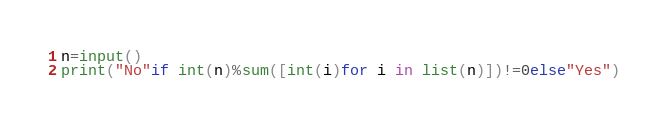<code> <loc_0><loc_0><loc_500><loc_500><_Python_>n=input()
print("No"if int(n)%sum([int(i)for i in list(n)])!=0else"Yes")
</code> 